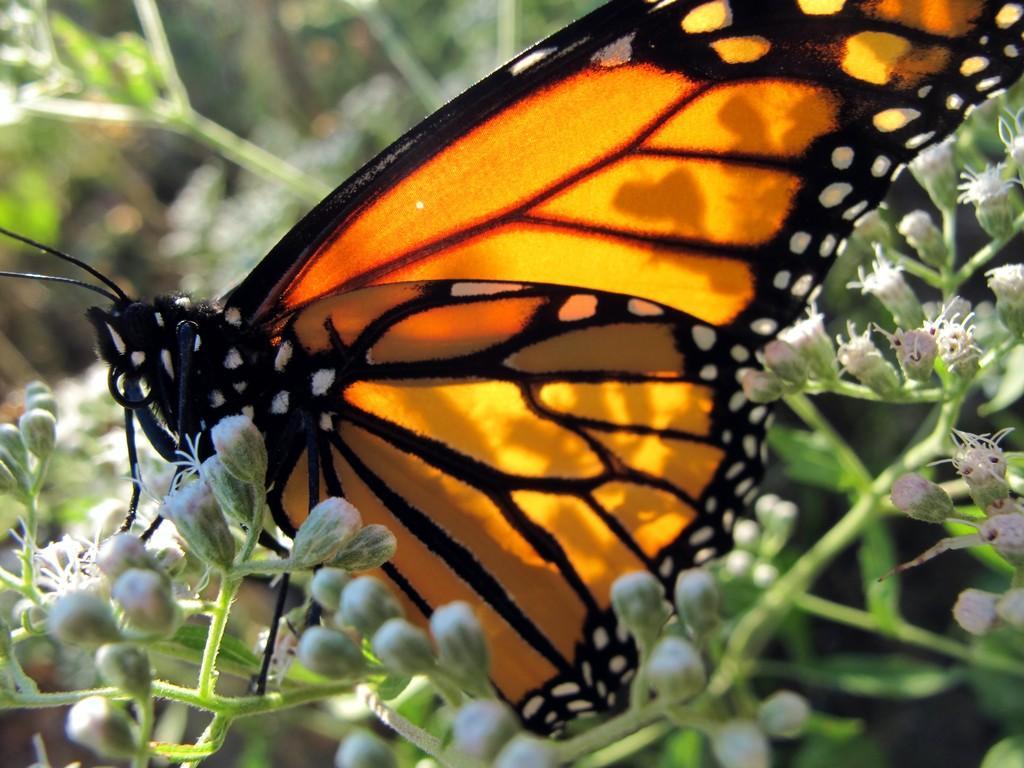How would you summarize this image in a sentence or two? In this image in the center there is a butterfly on flowers, and there is a blurry background. 